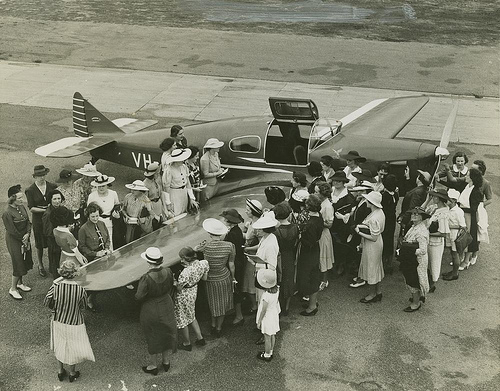What era does this image appear to represent? The image seems to depict a scene from the early to mid-20th century, judging by the style of clothing worn by the people and the design of the airplane. 